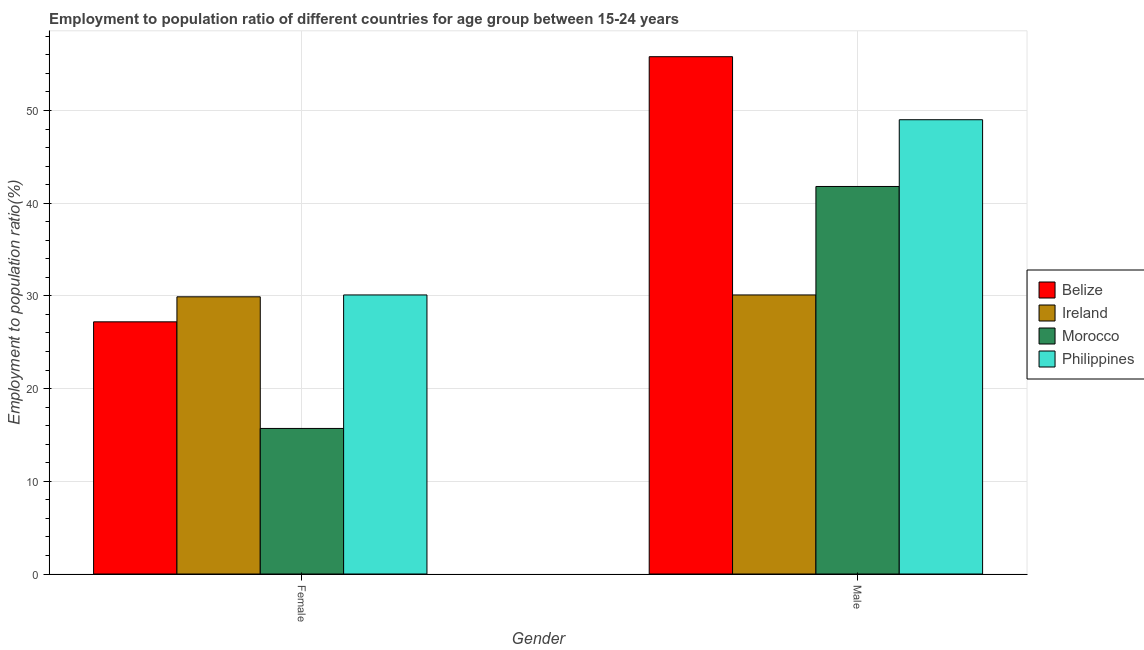How many groups of bars are there?
Provide a short and direct response. 2. How many bars are there on the 2nd tick from the left?
Your response must be concise. 4. What is the label of the 1st group of bars from the left?
Give a very brief answer. Female. What is the employment to population ratio(male) in Ireland?
Keep it short and to the point. 30.1. Across all countries, what is the maximum employment to population ratio(male)?
Your answer should be compact. 55.8. Across all countries, what is the minimum employment to population ratio(female)?
Your answer should be compact. 15.7. In which country was the employment to population ratio(female) maximum?
Your answer should be very brief. Philippines. In which country was the employment to population ratio(female) minimum?
Make the answer very short. Morocco. What is the total employment to population ratio(female) in the graph?
Offer a terse response. 102.9. What is the difference between the employment to population ratio(female) in Philippines and that in Ireland?
Offer a terse response. 0.2. What is the difference between the employment to population ratio(female) in Morocco and the employment to population ratio(male) in Belize?
Offer a very short reply. -40.1. What is the average employment to population ratio(female) per country?
Your response must be concise. 25.73. What is the difference between the employment to population ratio(male) and employment to population ratio(female) in Morocco?
Offer a terse response. 26.1. In how many countries, is the employment to population ratio(female) greater than 22 %?
Offer a very short reply. 3. What is the ratio of the employment to population ratio(male) in Morocco to that in Philippines?
Provide a succinct answer. 0.85. What does the 3rd bar from the left in Male represents?
Give a very brief answer. Morocco. How many bars are there?
Ensure brevity in your answer.  8. How many countries are there in the graph?
Provide a succinct answer. 4. What is the difference between two consecutive major ticks on the Y-axis?
Offer a terse response. 10. Are the values on the major ticks of Y-axis written in scientific E-notation?
Your response must be concise. No. Does the graph contain any zero values?
Offer a terse response. No. Where does the legend appear in the graph?
Ensure brevity in your answer.  Center right. How many legend labels are there?
Provide a succinct answer. 4. What is the title of the graph?
Provide a short and direct response. Employment to population ratio of different countries for age group between 15-24 years. What is the Employment to population ratio(%) in Belize in Female?
Your answer should be compact. 27.2. What is the Employment to population ratio(%) of Ireland in Female?
Provide a succinct answer. 29.9. What is the Employment to population ratio(%) of Morocco in Female?
Ensure brevity in your answer.  15.7. What is the Employment to population ratio(%) in Philippines in Female?
Ensure brevity in your answer.  30.1. What is the Employment to population ratio(%) in Belize in Male?
Provide a short and direct response. 55.8. What is the Employment to population ratio(%) in Ireland in Male?
Ensure brevity in your answer.  30.1. What is the Employment to population ratio(%) in Morocco in Male?
Your answer should be very brief. 41.8. What is the Employment to population ratio(%) in Philippines in Male?
Ensure brevity in your answer.  49. Across all Gender, what is the maximum Employment to population ratio(%) in Belize?
Give a very brief answer. 55.8. Across all Gender, what is the maximum Employment to population ratio(%) of Ireland?
Keep it short and to the point. 30.1. Across all Gender, what is the maximum Employment to population ratio(%) of Morocco?
Keep it short and to the point. 41.8. Across all Gender, what is the maximum Employment to population ratio(%) in Philippines?
Give a very brief answer. 49. Across all Gender, what is the minimum Employment to population ratio(%) of Belize?
Provide a succinct answer. 27.2. Across all Gender, what is the minimum Employment to population ratio(%) of Ireland?
Give a very brief answer. 29.9. Across all Gender, what is the minimum Employment to population ratio(%) in Morocco?
Give a very brief answer. 15.7. Across all Gender, what is the minimum Employment to population ratio(%) in Philippines?
Keep it short and to the point. 30.1. What is the total Employment to population ratio(%) of Belize in the graph?
Give a very brief answer. 83. What is the total Employment to population ratio(%) of Morocco in the graph?
Provide a short and direct response. 57.5. What is the total Employment to population ratio(%) in Philippines in the graph?
Ensure brevity in your answer.  79.1. What is the difference between the Employment to population ratio(%) of Belize in Female and that in Male?
Your response must be concise. -28.6. What is the difference between the Employment to population ratio(%) of Morocco in Female and that in Male?
Your answer should be compact. -26.1. What is the difference between the Employment to population ratio(%) of Philippines in Female and that in Male?
Ensure brevity in your answer.  -18.9. What is the difference between the Employment to population ratio(%) of Belize in Female and the Employment to population ratio(%) of Ireland in Male?
Offer a terse response. -2.9. What is the difference between the Employment to population ratio(%) of Belize in Female and the Employment to population ratio(%) of Morocco in Male?
Your answer should be very brief. -14.6. What is the difference between the Employment to population ratio(%) of Belize in Female and the Employment to population ratio(%) of Philippines in Male?
Make the answer very short. -21.8. What is the difference between the Employment to population ratio(%) of Ireland in Female and the Employment to population ratio(%) of Philippines in Male?
Give a very brief answer. -19.1. What is the difference between the Employment to population ratio(%) in Morocco in Female and the Employment to population ratio(%) in Philippines in Male?
Your response must be concise. -33.3. What is the average Employment to population ratio(%) of Belize per Gender?
Offer a very short reply. 41.5. What is the average Employment to population ratio(%) in Morocco per Gender?
Your answer should be compact. 28.75. What is the average Employment to population ratio(%) of Philippines per Gender?
Make the answer very short. 39.55. What is the difference between the Employment to population ratio(%) of Belize and Employment to population ratio(%) of Ireland in Female?
Your answer should be compact. -2.7. What is the difference between the Employment to population ratio(%) in Belize and Employment to population ratio(%) in Morocco in Female?
Keep it short and to the point. 11.5. What is the difference between the Employment to population ratio(%) in Belize and Employment to population ratio(%) in Philippines in Female?
Your response must be concise. -2.9. What is the difference between the Employment to population ratio(%) of Morocco and Employment to population ratio(%) of Philippines in Female?
Offer a terse response. -14.4. What is the difference between the Employment to population ratio(%) in Belize and Employment to population ratio(%) in Ireland in Male?
Provide a succinct answer. 25.7. What is the difference between the Employment to population ratio(%) of Belize and Employment to population ratio(%) of Philippines in Male?
Give a very brief answer. 6.8. What is the difference between the Employment to population ratio(%) of Ireland and Employment to population ratio(%) of Philippines in Male?
Give a very brief answer. -18.9. What is the ratio of the Employment to population ratio(%) in Belize in Female to that in Male?
Give a very brief answer. 0.49. What is the ratio of the Employment to population ratio(%) of Ireland in Female to that in Male?
Give a very brief answer. 0.99. What is the ratio of the Employment to population ratio(%) of Morocco in Female to that in Male?
Give a very brief answer. 0.38. What is the ratio of the Employment to population ratio(%) in Philippines in Female to that in Male?
Give a very brief answer. 0.61. What is the difference between the highest and the second highest Employment to population ratio(%) in Belize?
Give a very brief answer. 28.6. What is the difference between the highest and the second highest Employment to population ratio(%) of Morocco?
Make the answer very short. 26.1. What is the difference between the highest and the second highest Employment to population ratio(%) in Philippines?
Provide a short and direct response. 18.9. What is the difference between the highest and the lowest Employment to population ratio(%) of Belize?
Your response must be concise. 28.6. What is the difference between the highest and the lowest Employment to population ratio(%) in Morocco?
Make the answer very short. 26.1. What is the difference between the highest and the lowest Employment to population ratio(%) of Philippines?
Provide a short and direct response. 18.9. 